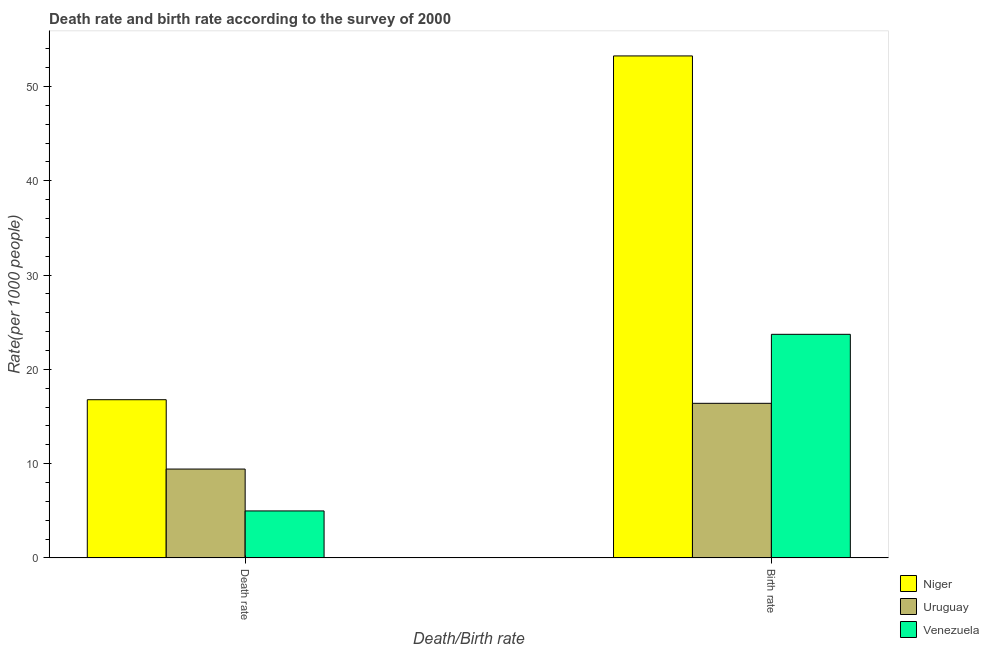How many different coloured bars are there?
Provide a short and direct response. 3. How many groups of bars are there?
Keep it short and to the point. 2. How many bars are there on the 1st tick from the right?
Provide a short and direct response. 3. What is the label of the 1st group of bars from the left?
Make the answer very short. Death rate. What is the death rate in Uruguay?
Give a very brief answer. 9.42. Across all countries, what is the maximum birth rate?
Keep it short and to the point. 53.25. Across all countries, what is the minimum birth rate?
Offer a very short reply. 16.4. In which country was the birth rate maximum?
Provide a succinct answer. Niger. In which country was the death rate minimum?
Provide a short and direct response. Venezuela. What is the total death rate in the graph?
Provide a succinct answer. 31.19. What is the difference between the birth rate in Niger and that in Uruguay?
Ensure brevity in your answer.  36.85. What is the difference between the birth rate in Niger and the death rate in Uruguay?
Provide a short and direct response. 43.83. What is the average birth rate per country?
Your response must be concise. 31.12. What is the difference between the birth rate and death rate in Niger?
Offer a very short reply. 36.47. What is the ratio of the birth rate in Uruguay to that in Venezuela?
Your answer should be compact. 0.69. What does the 3rd bar from the left in Birth rate represents?
Keep it short and to the point. Venezuela. What does the 2nd bar from the right in Death rate represents?
Offer a very short reply. Uruguay. How many bars are there?
Keep it short and to the point. 6. Are the values on the major ticks of Y-axis written in scientific E-notation?
Make the answer very short. No. Does the graph contain any zero values?
Provide a succinct answer. No. Where does the legend appear in the graph?
Provide a succinct answer. Bottom right. How many legend labels are there?
Ensure brevity in your answer.  3. How are the legend labels stacked?
Offer a very short reply. Vertical. What is the title of the graph?
Make the answer very short. Death rate and birth rate according to the survey of 2000. What is the label or title of the X-axis?
Provide a succinct answer. Death/Birth rate. What is the label or title of the Y-axis?
Keep it short and to the point. Rate(per 1000 people). What is the Rate(per 1000 people) in Niger in Death rate?
Give a very brief answer. 16.78. What is the Rate(per 1000 people) in Uruguay in Death rate?
Give a very brief answer. 9.42. What is the Rate(per 1000 people) of Venezuela in Death rate?
Provide a succinct answer. 4.98. What is the Rate(per 1000 people) in Niger in Birth rate?
Your response must be concise. 53.25. What is the Rate(per 1000 people) of Uruguay in Birth rate?
Make the answer very short. 16.4. What is the Rate(per 1000 people) of Venezuela in Birth rate?
Make the answer very short. 23.72. Across all Death/Birth rate, what is the maximum Rate(per 1000 people) in Niger?
Provide a short and direct response. 53.25. Across all Death/Birth rate, what is the maximum Rate(per 1000 people) of Uruguay?
Provide a short and direct response. 16.4. Across all Death/Birth rate, what is the maximum Rate(per 1000 people) of Venezuela?
Make the answer very short. 23.72. Across all Death/Birth rate, what is the minimum Rate(per 1000 people) of Niger?
Ensure brevity in your answer.  16.78. Across all Death/Birth rate, what is the minimum Rate(per 1000 people) of Uruguay?
Give a very brief answer. 9.42. Across all Death/Birth rate, what is the minimum Rate(per 1000 people) in Venezuela?
Provide a short and direct response. 4.98. What is the total Rate(per 1000 people) in Niger in the graph?
Make the answer very short. 70.03. What is the total Rate(per 1000 people) of Uruguay in the graph?
Give a very brief answer. 25.82. What is the total Rate(per 1000 people) of Venezuela in the graph?
Keep it short and to the point. 28.7. What is the difference between the Rate(per 1000 people) in Niger in Death rate and that in Birth rate?
Make the answer very short. -36.47. What is the difference between the Rate(per 1000 people) of Uruguay in Death rate and that in Birth rate?
Your response must be concise. -6.97. What is the difference between the Rate(per 1000 people) in Venezuela in Death rate and that in Birth rate?
Give a very brief answer. -18.73. What is the difference between the Rate(per 1000 people) in Niger in Death rate and the Rate(per 1000 people) in Uruguay in Birth rate?
Your answer should be compact. 0.38. What is the difference between the Rate(per 1000 people) in Niger in Death rate and the Rate(per 1000 people) in Venezuela in Birth rate?
Ensure brevity in your answer.  -6.94. What is the difference between the Rate(per 1000 people) of Uruguay in Death rate and the Rate(per 1000 people) of Venezuela in Birth rate?
Ensure brevity in your answer.  -14.29. What is the average Rate(per 1000 people) of Niger per Death/Birth rate?
Make the answer very short. 35.02. What is the average Rate(per 1000 people) in Uruguay per Death/Birth rate?
Your answer should be very brief. 12.91. What is the average Rate(per 1000 people) of Venezuela per Death/Birth rate?
Offer a very short reply. 14.35. What is the difference between the Rate(per 1000 people) of Niger and Rate(per 1000 people) of Uruguay in Death rate?
Your response must be concise. 7.36. What is the difference between the Rate(per 1000 people) in Niger and Rate(per 1000 people) in Venezuela in Death rate?
Make the answer very short. 11.8. What is the difference between the Rate(per 1000 people) in Uruguay and Rate(per 1000 people) in Venezuela in Death rate?
Make the answer very short. 4.44. What is the difference between the Rate(per 1000 people) in Niger and Rate(per 1000 people) in Uruguay in Birth rate?
Your response must be concise. 36.85. What is the difference between the Rate(per 1000 people) of Niger and Rate(per 1000 people) of Venezuela in Birth rate?
Give a very brief answer. 29.53. What is the difference between the Rate(per 1000 people) of Uruguay and Rate(per 1000 people) of Venezuela in Birth rate?
Make the answer very short. -7.32. What is the ratio of the Rate(per 1000 people) in Niger in Death rate to that in Birth rate?
Offer a very short reply. 0.32. What is the ratio of the Rate(per 1000 people) in Uruguay in Death rate to that in Birth rate?
Provide a short and direct response. 0.57. What is the ratio of the Rate(per 1000 people) of Venezuela in Death rate to that in Birth rate?
Keep it short and to the point. 0.21. What is the difference between the highest and the second highest Rate(per 1000 people) in Niger?
Keep it short and to the point. 36.47. What is the difference between the highest and the second highest Rate(per 1000 people) in Uruguay?
Offer a terse response. 6.97. What is the difference between the highest and the second highest Rate(per 1000 people) of Venezuela?
Keep it short and to the point. 18.73. What is the difference between the highest and the lowest Rate(per 1000 people) in Niger?
Your response must be concise. 36.47. What is the difference between the highest and the lowest Rate(per 1000 people) in Uruguay?
Provide a succinct answer. 6.97. What is the difference between the highest and the lowest Rate(per 1000 people) in Venezuela?
Offer a very short reply. 18.73. 